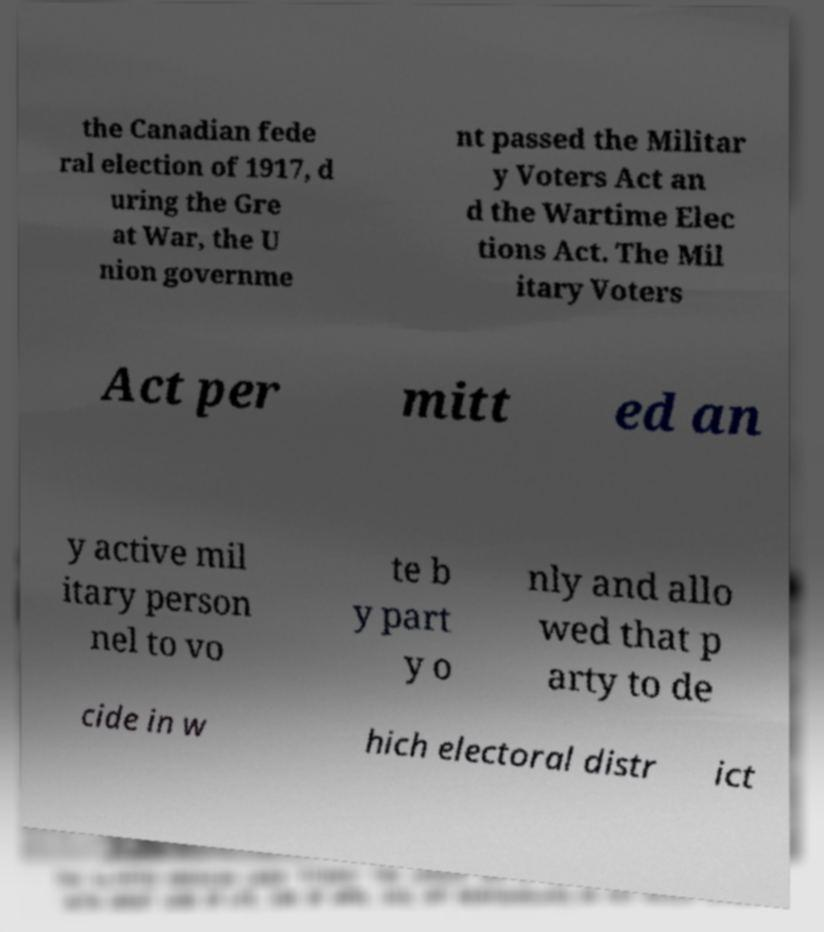Could you extract and type out the text from this image? the Canadian fede ral election of 1917, d uring the Gre at War, the U nion governme nt passed the Militar y Voters Act an d the Wartime Elec tions Act. The Mil itary Voters Act per mitt ed an y active mil itary person nel to vo te b y part y o nly and allo wed that p arty to de cide in w hich electoral distr ict 